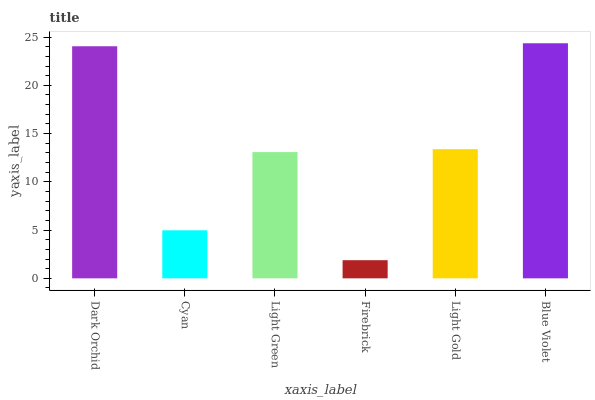Is Firebrick the minimum?
Answer yes or no. Yes. Is Blue Violet the maximum?
Answer yes or no. Yes. Is Cyan the minimum?
Answer yes or no. No. Is Cyan the maximum?
Answer yes or no. No. Is Dark Orchid greater than Cyan?
Answer yes or no. Yes. Is Cyan less than Dark Orchid?
Answer yes or no. Yes. Is Cyan greater than Dark Orchid?
Answer yes or no. No. Is Dark Orchid less than Cyan?
Answer yes or no. No. Is Light Gold the high median?
Answer yes or no. Yes. Is Light Green the low median?
Answer yes or no. Yes. Is Firebrick the high median?
Answer yes or no. No. Is Firebrick the low median?
Answer yes or no. No. 